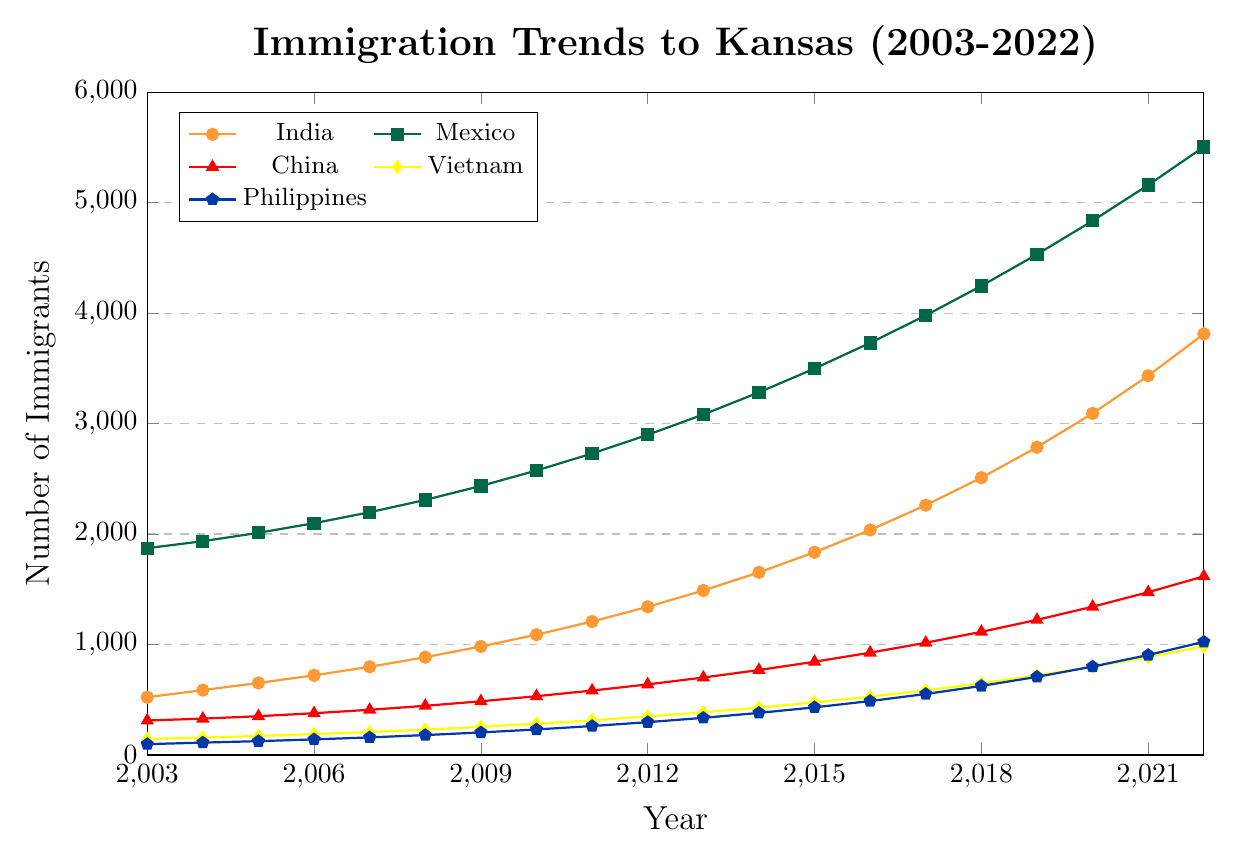What country had the highest number of immigrants to Kansas in 2022? Look at the end of the lines for each country in the year 2022. The highest point will indicate the highest number of immigrants.
Answer: Mexico Which country had the smallest increase in the number of immigrants from 2003 to 2022? Calculate the difference between the number of immigrants in 2022 and 2003 for each country and find the smallest difference.
Answer: Germany By how much did the number of immigrants from India increase from 2015 to 2019? Subtract the number of immigrants in 2015 from the number in 2019 for India. (2786 - 1835)
Answer: 951 Which country showed a greater increase in immigrants between 2010 and 2020, China or Vietnam? For both countries, subtract the number of immigrants in 2010 from the number in 2020, then compare both results. China: (1342 - 532 = 810), Vietnam: (799 - 283 = 516)
Answer: China What is the average annual number of immigrants from the Philippines from 2003 to 2013? Add up the number of immigrants from the Philippines from 2003 to 2013 and divide by the number of years (11). (98 + 112 + 125 + 141 + 159 + 180 + 204 + 231 + 262 + 297 + 336)/11 = 2045/11
Answer: 186 Which year did South Korea surpass 500 immigrants? Look at the trend line for South Korea and identify the first year the value exceeds 500.
Answer: 2018 What is the total number of immigrants to Kansas from Brazil and Nigeria combined in 2020? Add the number of immigrants from Brazil and Nigeria in 2020. (493 + 406)
Answer: 899 How did the total number of immigrants from Mexico change from 2018 to 2022? Subtract the number of immigrants in 2018 from the number in 2022 for Mexico. (5504 - 4246)
Answer: 1258 Which country had the smallest number of immigrants in 2007, and what was the value? Look at the data for the year 2007 and identify the smallest value and associated country.
Answer: Nigeria, 57 